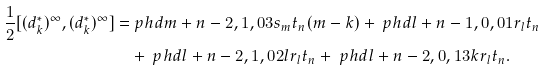<formula> <loc_0><loc_0><loc_500><loc_500>\frac { 1 } { 2 } [ ( d _ { k } ^ { * } ) ^ { \infty } , ( d _ { k } ^ { * } ) ^ { \infty } ] = & \ p h d { m + n - 2 , 1 , 0 } 3 s _ { m } t _ { n } ( m - k ) + \ p h d { l + n - 1 , 0 , 0 } 1 r _ { l } t _ { n } \\ & + \ p h d { l + n - 2 , 1 , 0 } 2 l r _ { l } t _ { n } + \ p h d { l + n - 2 , 0 , 1 } 3 k r _ { l } t _ { n } .</formula> 